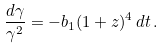Convert formula to latex. <formula><loc_0><loc_0><loc_500><loc_500>\frac { d \gamma } { \gamma ^ { 2 } } = - b _ { 1 } ( 1 + z ) ^ { 4 } \, d t \, .</formula> 